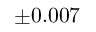Convert formula to latex. <formula><loc_0><loc_0><loc_500><loc_500>\pm 0 . 0 0 7</formula> 